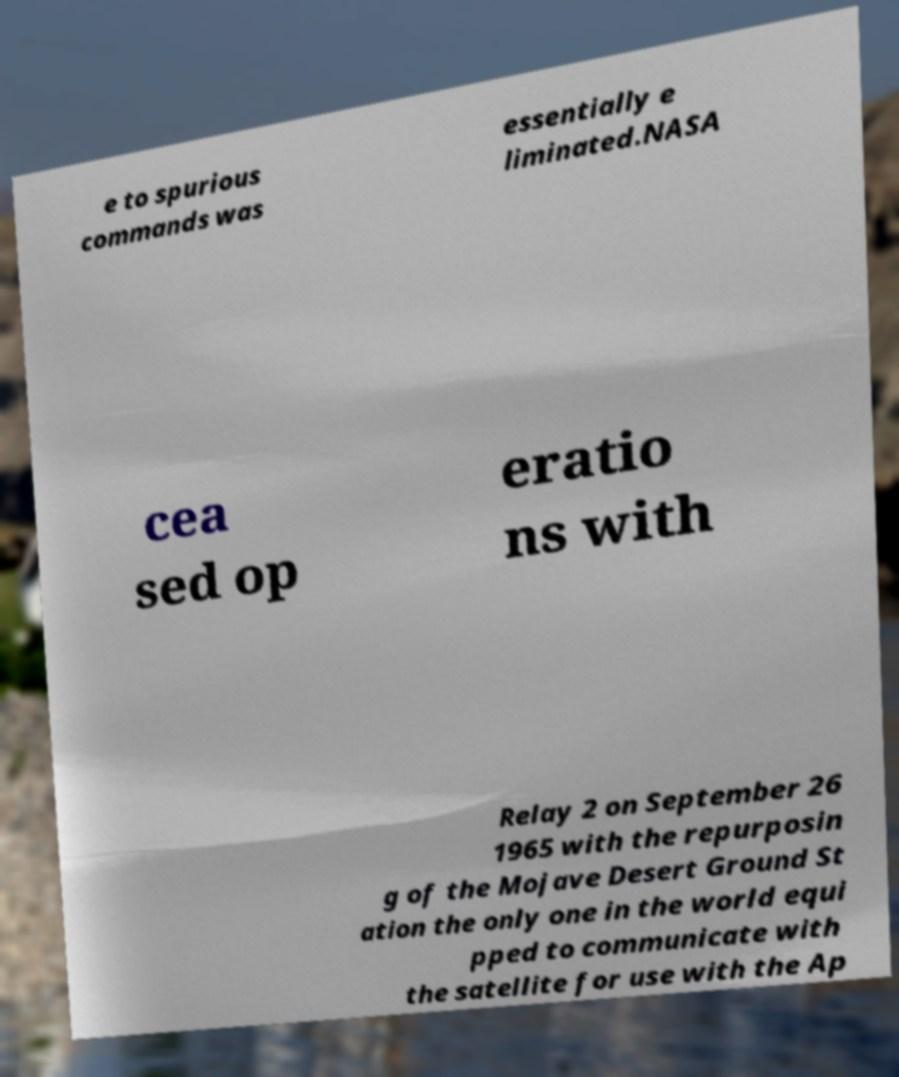Please identify and transcribe the text found in this image. e to spurious commands was essentially e liminated.NASA cea sed op eratio ns with Relay 2 on September 26 1965 with the repurposin g of the Mojave Desert Ground St ation the only one in the world equi pped to communicate with the satellite for use with the Ap 